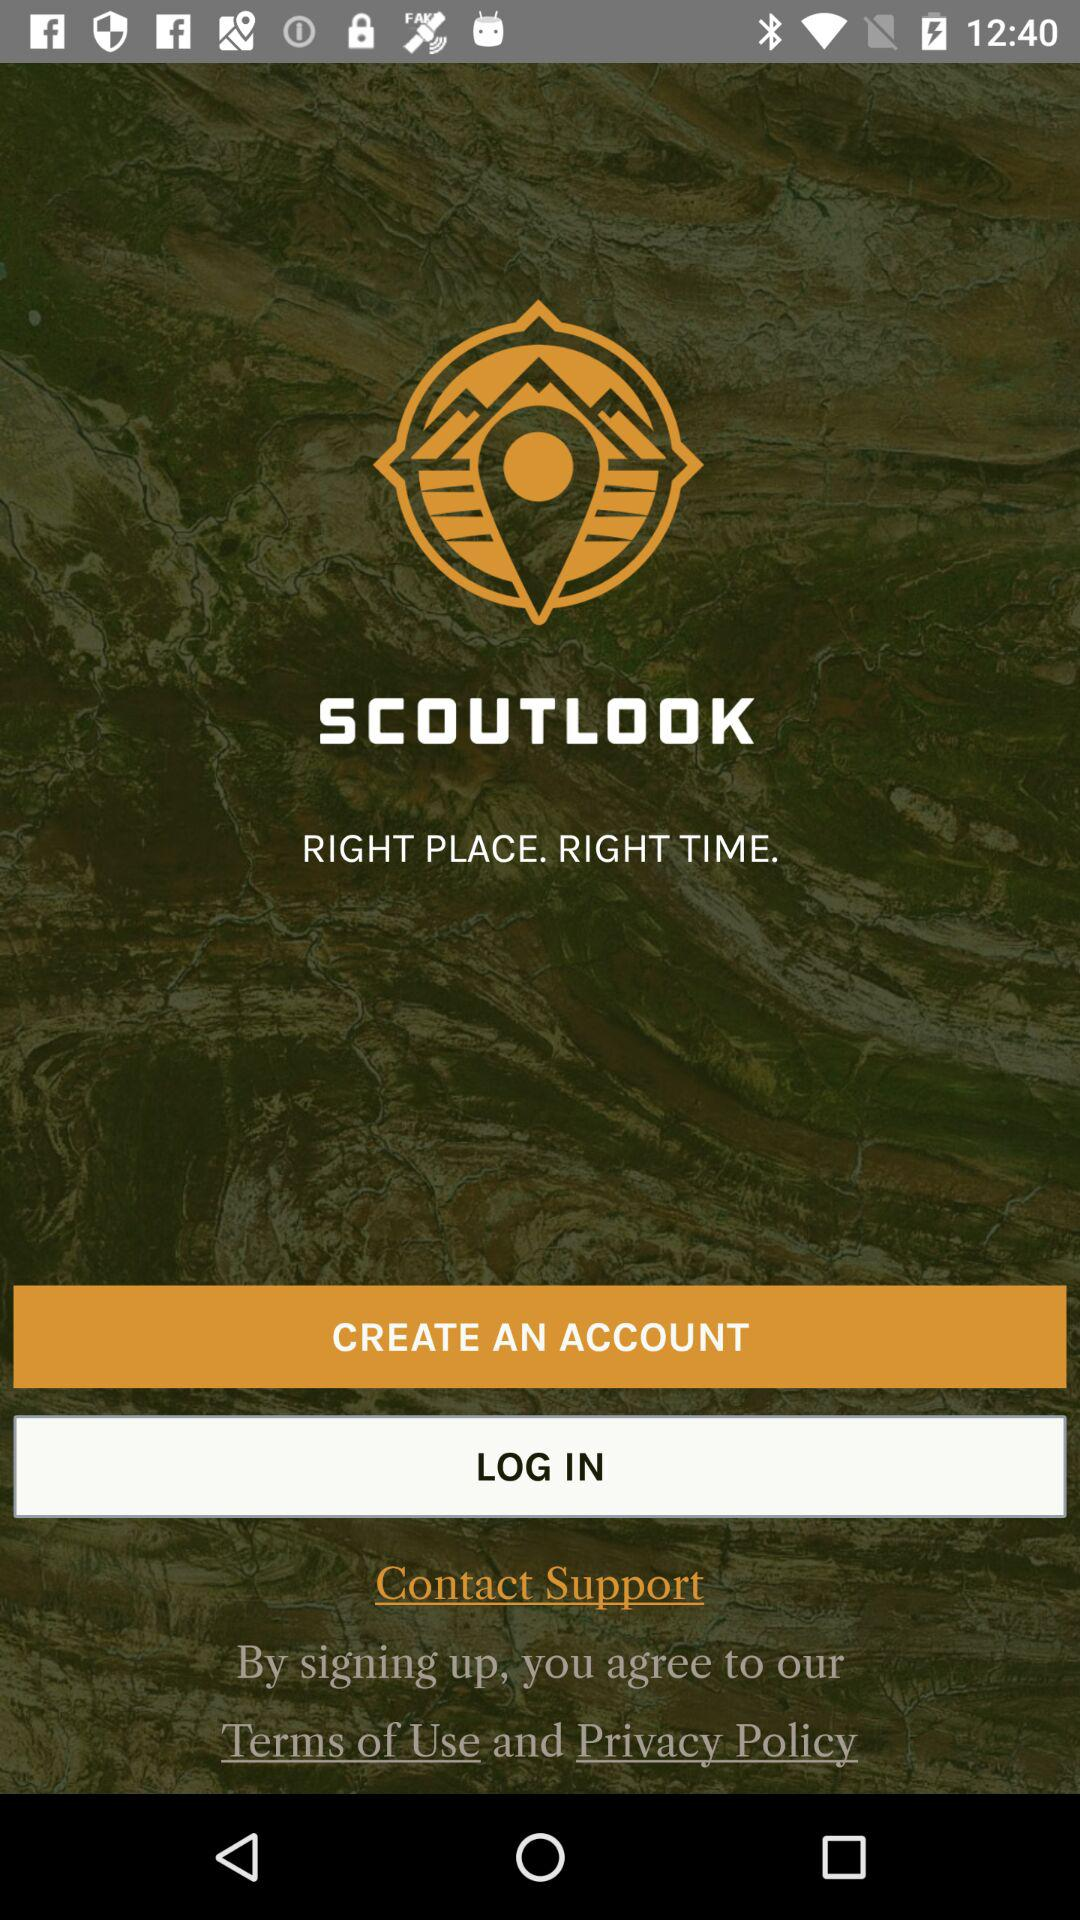What is the application name? The name of the application is "SCOUTLOOK". 